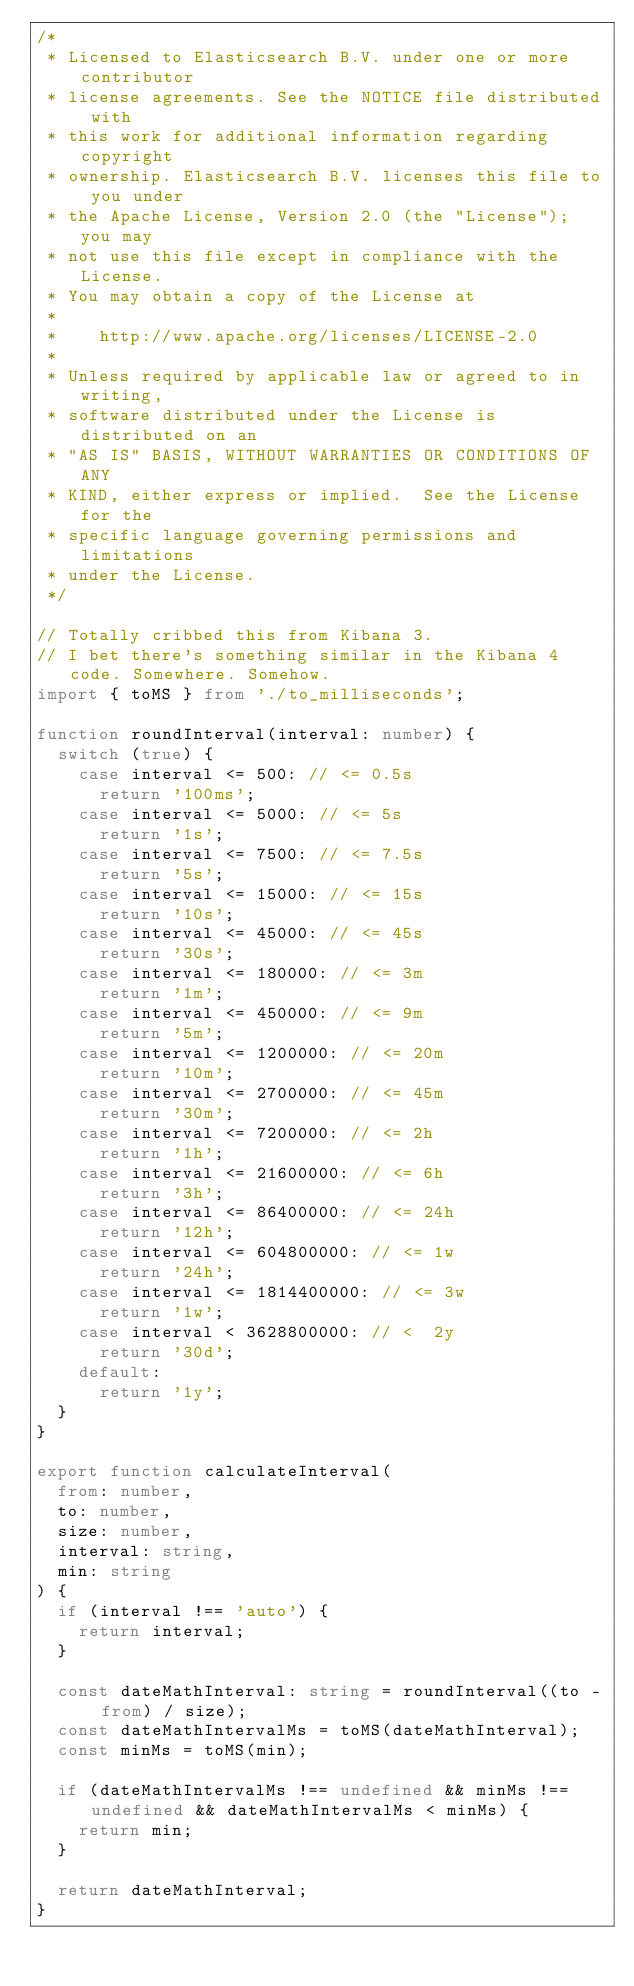Convert code to text. <code><loc_0><loc_0><loc_500><loc_500><_TypeScript_>/*
 * Licensed to Elasticsearch B.V. under one or more contributor
 * license agreements. See the NOTICE file distributed with
 * this work for additional information regarding copyright
 * ownership. Elasticsearch B.V. licenses this file to you under
 * the Apache License, Version 2.0 (the "License"); you may
 * not use this file except in compliance with the License.
 * You may obtain a copy of the License at
 *
 *    http://www.apache.org/licenses/LICENSE-2.0
 *
 * Unless required by applicable law or agreed to in writing,
 * software distributed under the License is distributed on an
 * "AS IS" BASIS, WITHOUT WARRANTIES OR CONDITIONS OF ANY
 * KIND, either express or implied.  See the License for the
 * specific language governing permissions and limitations
 * under the License.
 */

// Totally cribbed this from Kibana 3.
// I bet there's something similar in the Kibana 4 code. Somewhere. Somehow.
import { toMS } from './to_milliseconds';

function roundInterval(interval: number) {
  switch (true) {
    case interval <= 500: // <= 0.5s
      return '100ms';
    case interval <= 5000: // <= 5s
      return '1s';
    case interval <= 7500: // <= 7.5s
      return '5s';
    case interval <= 15000: // <= 15s
      return '10s';
    case interval <= 45000: // <= 45s
      return '30s';
    case interval <= 180000: // <= 3m
      return '1m';
    case interval <= 450000: // <= 9m
      return '5m';
    case interval <= 1200000: // <= 20m
      return '10m';
    case interval <= 2700000: // <= 45m
      return '30m';
    case interval <= 7200000: // <= 2h
      return '1h';
    case interval <= 21600000: // <= 6h
      return '3h';
    case interval <= 86400000: // <= 24h
      return '12h';
    case interval <= 604800000: // <= 1w
      return '24h';
    case interval <= 1814400000: // <= 3w
      return '1w';
    case interval < 3628800000: // <  2y
      return '30d';
    default:
      return '1y';
  }
}

export function calculateInterval(
  from: number,
  to: number,
  size: number,
  interval: string,
  min: string
) {
  if (interval !== 'auto') {
    return interval;
  }

  const dateMathInterval: string = roundInterval((to - from) / size);
  const dateMathIntervalMs = toMS(dateMathInterval);
  const minMs = toMS(min);

  if (dateMathIntervalMs !== undefined && minMs !== undefined && dateMathIntervalMs < minMs) {
    return min;
  }

  return dateMathInterval;
}
</code> 